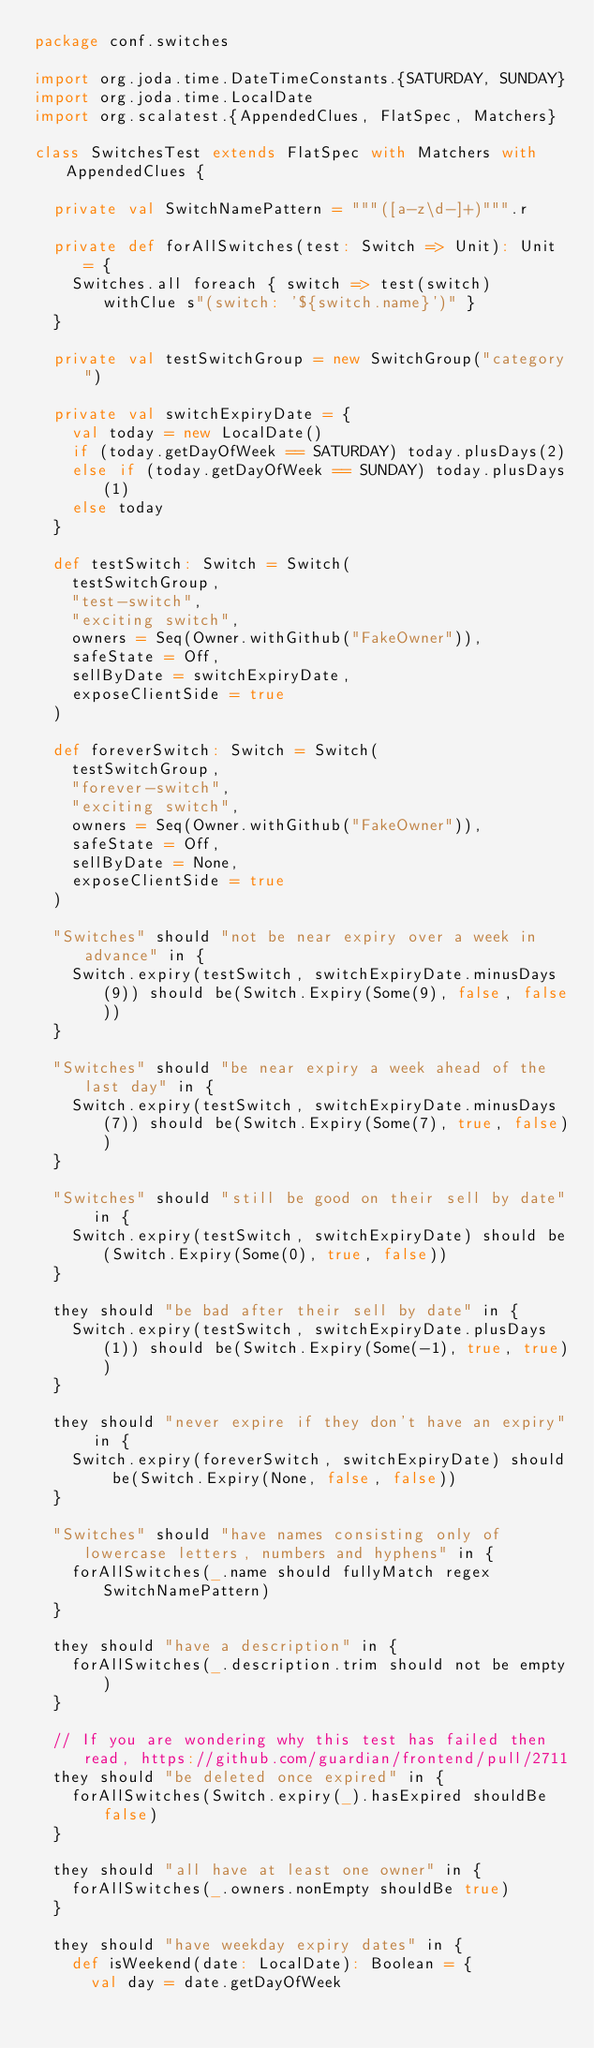<code> <loc_0><loc_0><loc_500><loc_500><_Scala_>package conf.switches

import org.joda.time.DateTimeConstants.{SATURDAY, SUNDAY}
import org.joda.time.LocalDate
import org.scalatest.{AppendedClues, FlatSpec, Matchers}

class SwitchesTest extends FlatSpec with Matchers with AppendedClues {

  private val SwitchNamePattern = """([a-z\d-]+)""".r

  private def forAllSwitches(test: Switch => Unit): Unit = {
    Switches.all foreach { switch => test(switch) withClue s"(switch: '${switch.name}')" }
  }

  private val testSwitchGroup = new SwitchGroup("category")

  private val switchExpiryDate = {
    val today = new LocalDate()
    if (today.getDayOfWeek == SATURDAY) today.plusDays(2)
    else if (today.getDayOfWeek == SUNDAY) today.plusDays(1)
    else today
  }

  def testSwitch: Switch = Switch(
    testSwitchGroup,
    "test-switch",
    "exciting switch",
    owners = Seq(Owner.withGithub("FakeOwner")),
    safeState = Off,
    sellByDate = switchExpiryDate,
    exposeClientSide = true
  )

  def foreverSwitch: Switch = Switch(
    testSwitchGroup,
    "forever-switch",
    "exciting switch",
    owners = Seq(Owner.withGithub("FakeOwner")),
    safeState = Off,
    sellByDate = None,
    exposeClientSide = true
  )

  "Switches" should "not be near expiry over a week in advance" in {
    Switch.expiry(testSwitch, switchExpiryDate.minusDays(9)) should be(Switch.Expiry(Some(9), false, false))
  }

  "Switches" should "be near expiry a week ahead of the last day" in {
    Switch.expiry(testSwitch, switchExpiryDate.minusDays(7)) should be(Switch.Expiry(Some(7), true, false))
  }

  "Switches" should "still be good on their sell by date" in {
    Switch.expiry(testSwitch, switchExpiryDate) should be(Switch.Expiry(Some(0), true, false))
  }

  they should "be bad after their sell by date" in {
    Switch.expiry(testSwitch, switchExpiryDate.plusDays(1)) should be(Switch.Expiry(Some(-1), true, true))
  }

  they should "never expire if they don't have an expiry" in {
    Switch.expiry(foreverSwitch, switchExpiryDate) should be(Switch.Expiry(None, false, false))
  }

  "Switches" should "have names consisting only of lowercase letters, numbers and hyphens" in {
    forAllSwitches(_.name should fullyMatch regex SwitchNamePattern)
  }

  they should "have a description" in {
    forAllSwitches(_.description.trim should not be empty)
  }

  // If you are wondering why this test has failed then read, https://github.com/guardian/frontend/pull/2711
  they should "be deleted once expired" in {
    forAllSwitches(Switch.expiry(_).hasExpired shouldBe false)
  }

  they should "all have at least one owner" in {
    forAllSwitches(_.owners.nonEmpty shouldBe true)
  }

  they should "have weekday expiry dates" in {
    def isWeekend(date: LocalDate): Boolean = {
      val day = date.getDayOfWeek</code> 